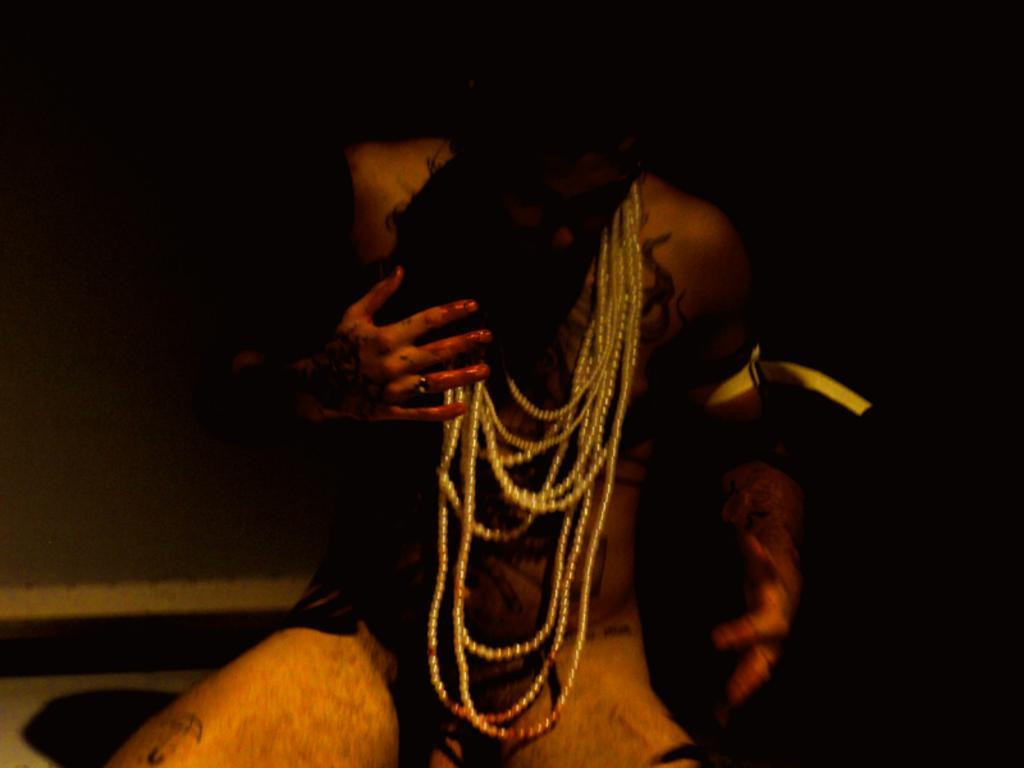Can you describe this image briefly? This image consists of a person wearing ornaments. The background is dark. At the bottom, there is a floor. 